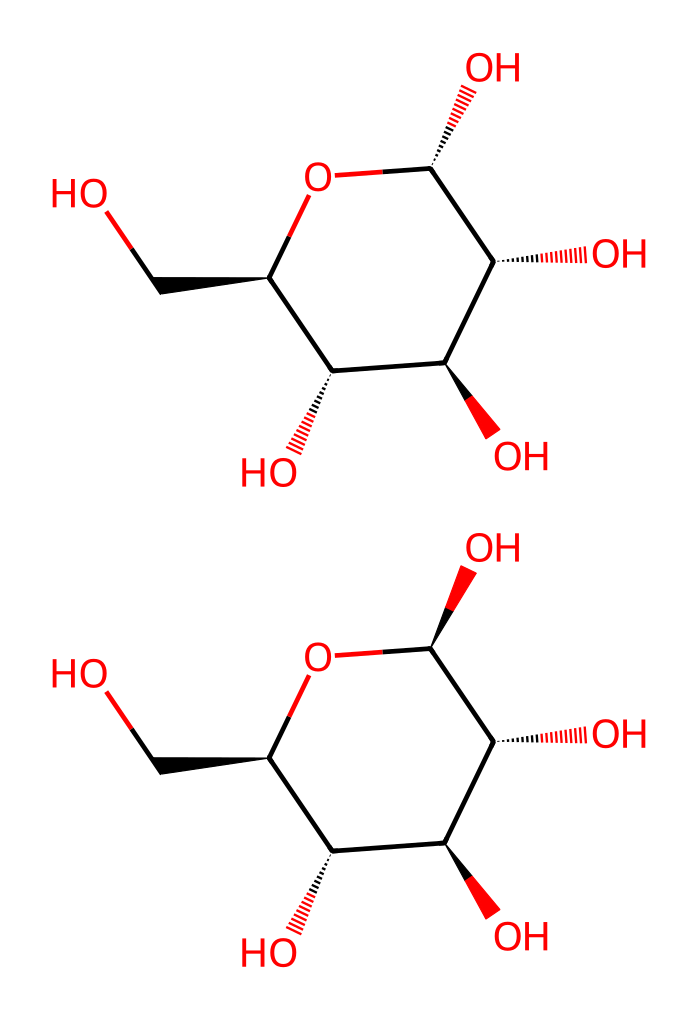What is the molecular formula of glucose? By counting the number of carbon (C), hydrogen (H), and oxygen (O) atoms from the structure's representation, glucose has 6 carbon atoms, 12 hydrogen atoms, and 6 oxygen atoms, leading to the molecular formula C6H12O6.
Answer: C6H12O6 How many chirality centers are present in glucose? Upon analyzing the chemical structure, there are four carbon atoms (C) connected to different groups, indicating they are chiral centers. This results from the presence of different substituents on each chiral carbon.
Answer: four What distinguishes the alpha anomer from the beta anomer in glucose? The distinction between alpha and beta anomers is based on the orientation of the hydroxyl group (-OH) attached to the first carbon when in a cyclic form. In alpha glucose, this -OH group is on the opposite side of the CH2OH group (down), while in beta glucose, it is on the same side (up).
Answer: orientation of hydroxyl group What is the configuration of the anomeric carbon in the beta anomer of glucose? The anomeric carbon is the carbon that forms the new stereocenter during the formation of the cyclic structure. In beta glucose, this carbon (the first carbon) has the hydroxyl group oriented upwards, resulting in an (R) configuration.
Answer: (R) What type of linkage forms when glucose monomers polymerize? When glucose monomers join together, they form glycosidic bonds, which are formed by a dehydration reaction between the hydroxyl groups of the glucose monomers. This creates a covalent linkage that holds the sugars together in polysaccharides.
Answer: glycosidic bond How many total oxygen atoms are present in the structure of glucose? By reviewing the chemical structure, we can count the number of oxygen atoms (O) present, which includes those in the hydroxyl groups and the ring structure. There are six oxygen atoms in total.
Answer: six 